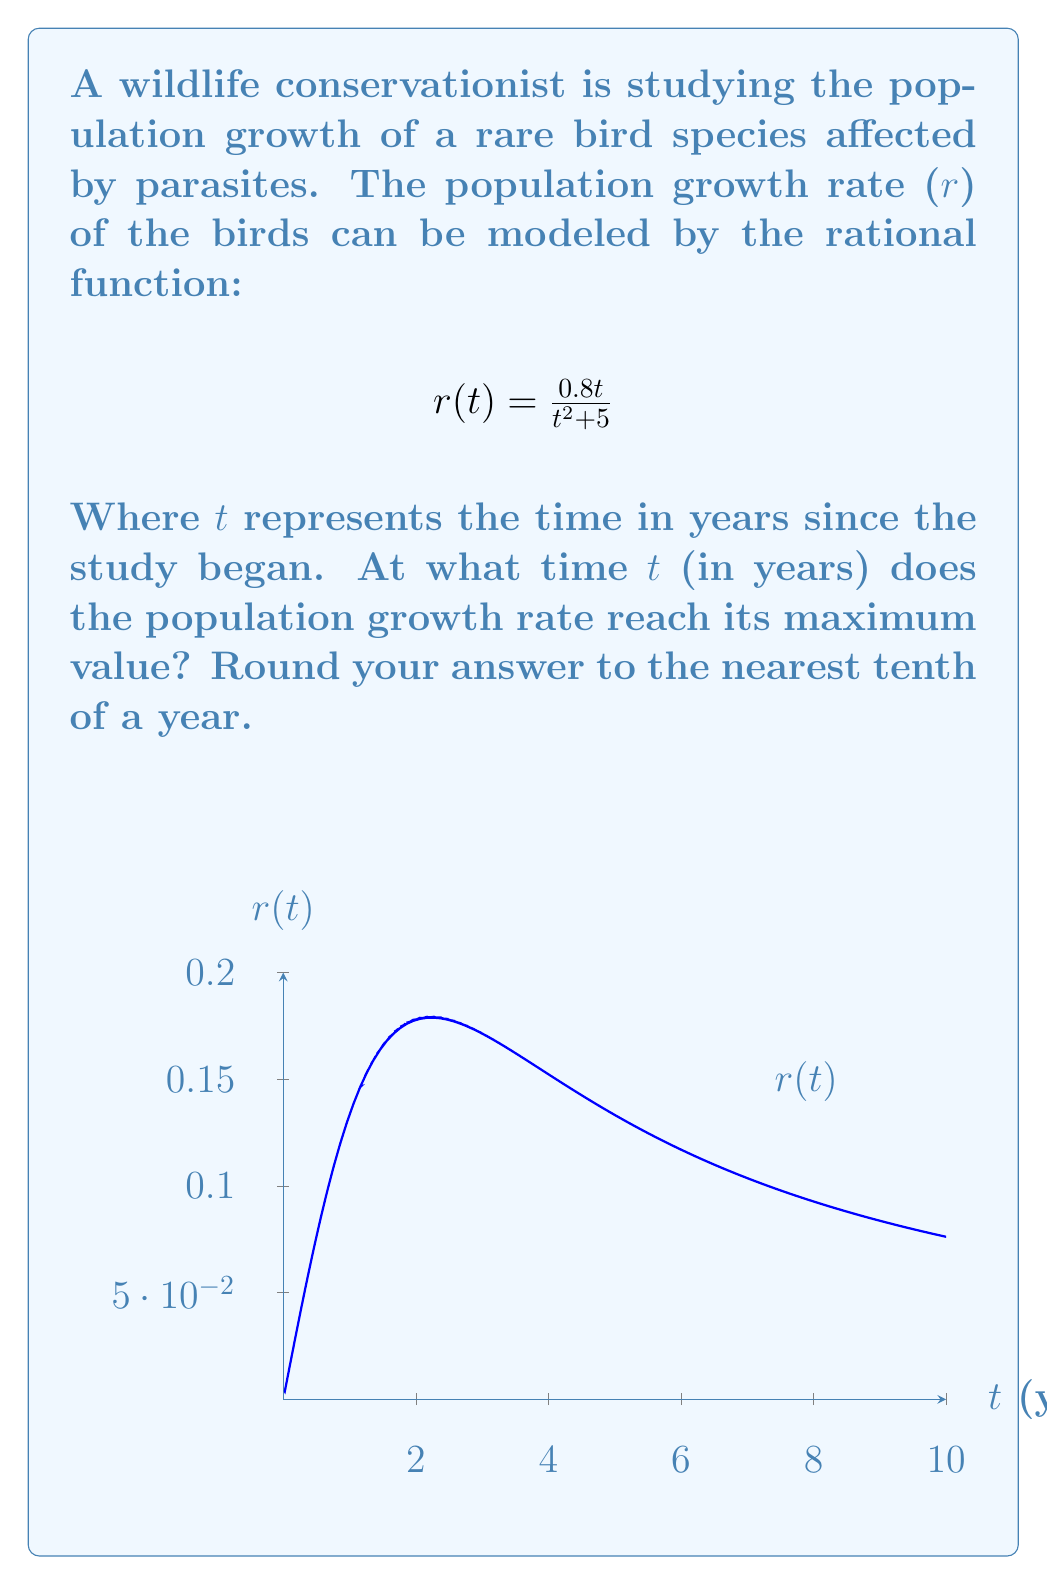Solve this math problem. To find the maximum value of the rational function, we need to follow these steps:

1) First, we need to find the derivative of r(t):
   $$r'(t) = \frac{(0.8)(t^2+5) - (0.8t)(2t)}{(t^2+5)^2}$$
   $$= \frac{0.8t^2 + 4 - 1.6t^2}{(t^2+5)^2}$$
   $$= \frac{4 - 0.8t^2}{(t^2+5)^2}$$

2) Set the derivative equal to zero and solve for t:
   $$\frac{4 - 0.8t^2}{(t^2+5)^2} = 0$$
   $$4 - 0.8t^2 = 0$$
   $$4 = 0.8t^2$$
   $$5 = t^2$$
   $$t = \sqrt{5} \approx 2.236$$

3) To confirm this is a maximum (not a minimum), we can check the second derivative or observe the behavior of the function.

4) Rounding to the nearest tenth:
   $$t \approx 2.2 \text{ years}$$

Therefore, the population growth rate reaches its maximum value approximately 2.2 years after the study began.
Answer: 2.2 years 